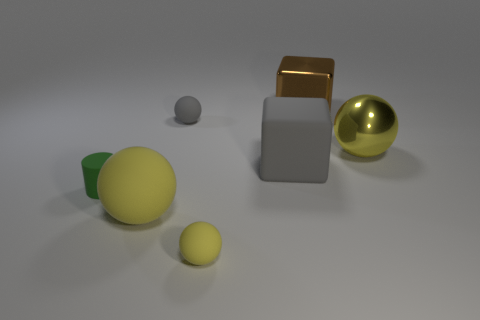Subtract all large rubber spheres. How many spheres are left? 3 Add 2 brown metallic cylinders. How many objects exist? 9 Subtract all yellow balls. How many balls are left? 1 Subtract 1 cylinders. How many cylinders are left? 0 Subtract all cubes. How many objects are left? 5 Subtract all green cylinders. How many yellow spheres are left? 3 Subtract all brown cubes. Subtract all purple spheres. How many cubes are left? 1 Add 2 metallic spheres. How many metallic spheres are left? 3 Add 2 small gray metallic things. How many small gray metallic things exist? 2 Subtract 0 cyan cubes. How many objects are left? 7 